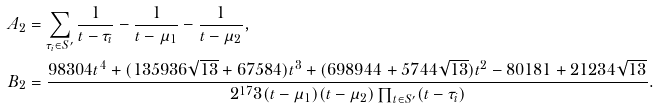Convert formula to latex. <formula><loc_0><loc_0><loc_500><loc_500>A _ { 2 } & = \sum _ { \tau _ { i } \in S ^ { \prime } } \frac { 1 } { t - \tau _ { i } } - \frac { 1 } { t - \mu _ { 1 } } - \frac { 1 } { t - \mu _ { 2 } } , \\ B _ { 2 } & = \frac { 9 8 3 0 4 t ^ { 4 } + ( 1 3 5 9 3 6 \sqrt { 1 3 } + 6 7 5 8 4 ) t ^ { 3 } + ( 6 9 8 9 4 4 + 5 7 4 4 \sqrt { 1 3 } ) t ^ { 2 } - 8 0 1 8 1 + 2 1 2 3 4 \sqrt { 1 3 } } { 2 ^ { 1 7 } 3 ( t - \mu _ { 1 } ) ( t - \mu _ { 2 } ) \prod _ { t \in S ^ { \prime } } ( t - \tau _ { i } ) } .</formula> 